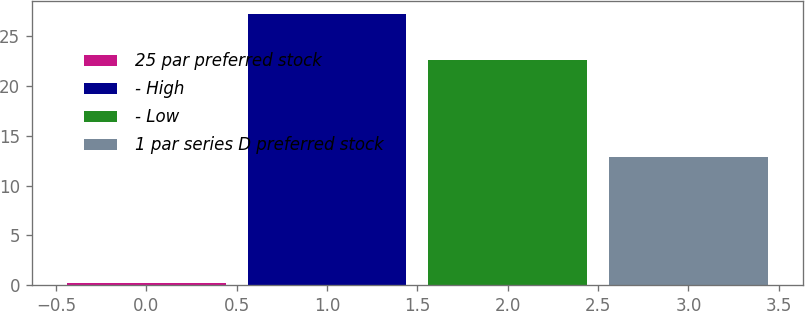<chart> <loc_0><loc_0><loc_500><loc_500><bar_chart><fcel>25 par preferred stock<fcel>- High<fcel>- Low<fcel>1 par series D preferred stock<nl><fcel>0.25<fcel>27.17<fcel>22.61<fcel>12.81<nl></chart> 